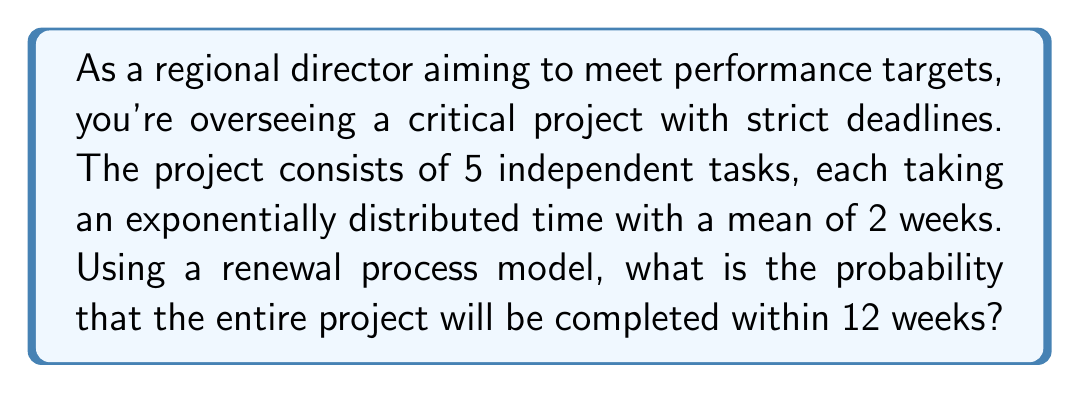Provide a solution to this math problem. Let's approach this step-by-step:

1) In a renewal process with exponentially distributed inter-arrival times, the number of events (in this case, completed tasks) in a given time follows a Poisson distribution.

2) The rate parameter λ for each task is the inverse of the mean time:
   $\lambda = \frac{1}{2}$ per week

3) For the entire project, we need all 5 tasks to be completed. The time for the project completion is the maximum of the 5 independent exponential random variables.

4) The probability that the project is completed within 12 weeks is equivalent to the probability that all 5 tasks are completed within 12 weeks.

5) For a Poisson process with rate λ, the probability of k or more events in time t is:

   $P(N(t) \geq k) = 1 - \sum_{i=0}^{k-1} \frac{e^{-\lambda t}(\lambda t)^i}{i!}$

6) In our case, k = 1 (we need at least one completion for each task), t = 12, and λ = 1/2:

   $P(\text{task completed in 12 weeks}) = 1 - e^{-12/2} = 1 - e^{-6}$

7) Since the tasks are independent, the probability that all 5 are completed is:

   $P(\text{all tasks completed}) = (1 - e^{-6})^5$

8) Calculating this:
   $(1 - e^{-6})^5 \approx (0.9975)^5 \approx 0.9876$

Therefore, the probability that the project will be completed within 12 weeks is approximately 0.9876 or 98.76%.
Answer: 0.9876 